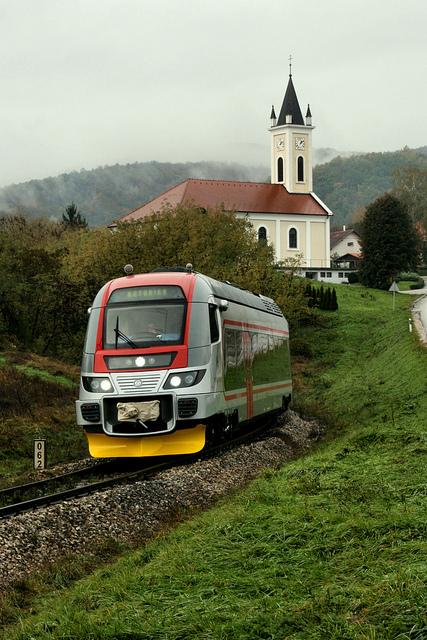What is the clock for?
Write a very short answer. Tell time. What is moving in the picture?
Concise answer only. Train. Where is the clock?
Short answer required. On church tower. 